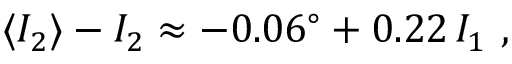<formula> <loc_0><loc_0><loc_500><loc_500>\langle I _ { 2 } \rangle - I _ { 2 } \approx - 0 . 0 6 ^ { \circ } + 0 . 2 2 \, I _ { 1 } \ ,</formula> 